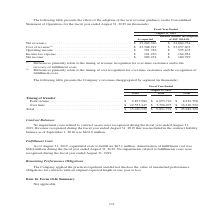According to Jabil Circuit's financial document, What do the differences in amount of net revenue between as reported and balance without the adoption of ASU 2014-09 primarily relate to? the timing of revenue recognition for over-time customers and to the recovery of fulfillment costs.. The document states: "(1) Differences primarily relate to the timing of revenue recognition for over-time customers and to the recovery of fulfillment costs. (2) Difference..." Also, What was the net revenue as reported? According to the financial document, $25,282,320 (in thousands). The relevant text states: "Net revenue (1) . $ 25,282,320 $ 24,864,754 Cost of revenue (2) . $ 23,368,919 $ 23,057,603 Operating income . $ 701,356 $ 595,105..." Also, What was the operating income as reported? According to the financial document, $701,356 (in thousands). The relevant text states: ". $ 23,368,919 $ 23,057,603 Operating income . $ 701,356 $ 595,105 Income tax expense . $ 161,230 $ 164,054 Net income . $ 289,474 $ 180,399..." Also, can you calculate: What was the difference between net revenue and cost of revenue as reported? Based on the calculation: 25,282,320-23,368,919, the result is 1913401 (in thousands). This is based on the information: "Net revenue (1) . $ 25,282,320 $ 24,864,754 Cost of revenue (2) . $ 23,368,919 $ 23,057,603 Operating income . $ 701,356 $ 595,105 $ 25,282,320 $ 24,864,754 Cost of revenue (2) . $ 23,368,919 $ 23,057..." The key data points involved are: 23,368,919, 25,282,320. Also, can you calculate: What was the operating income balance without the adoption of ASU 2014-09 as a ratio of the amount as reported? Based on the calculation: 595,105/701,356, the result is 84.85 (percentage). This is based on the information: ". $ 23,368,919 $ 23,057,603 Operating income . $ 701,356 $ 595,105 Income tax expense . $ 161,230 $ 164,054 Net income . $ 289,474 $ 180,399 8,919 $ 23,057,603 Operating income . $ 701,356 $ 595,105 I..." The key data points involved are: 595,105, 701,356. Also, can you calculate: What was the difference in the net income between the amount as reported and the balance without the adoption of ASU 2014-09? Based on the calculation: 289,474-180,399, the result is 109075 (in thousands). This is based on the information: "se . $ 161,230 $ 164,054 Net income . $ 289,474 $ 180,399 tax expense . $ 161,230 $ 164,054 Net income . $ 289,474 $ 180,399..." The key data points involved are: 180,399, 289,474. 